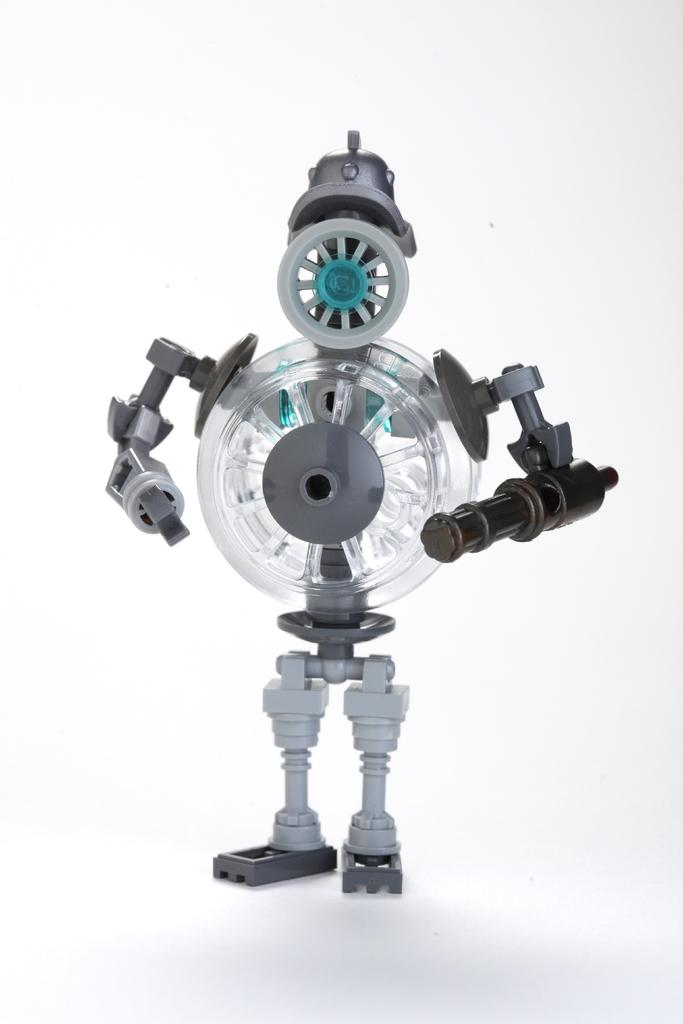What is the main subject of the image? There is a robot in the image. What color is the background of the image? The background of the image is white. Can you tell me who created the goldfish in the image? There is no goldfish present in the image, so it is not possible to determine who created it. 